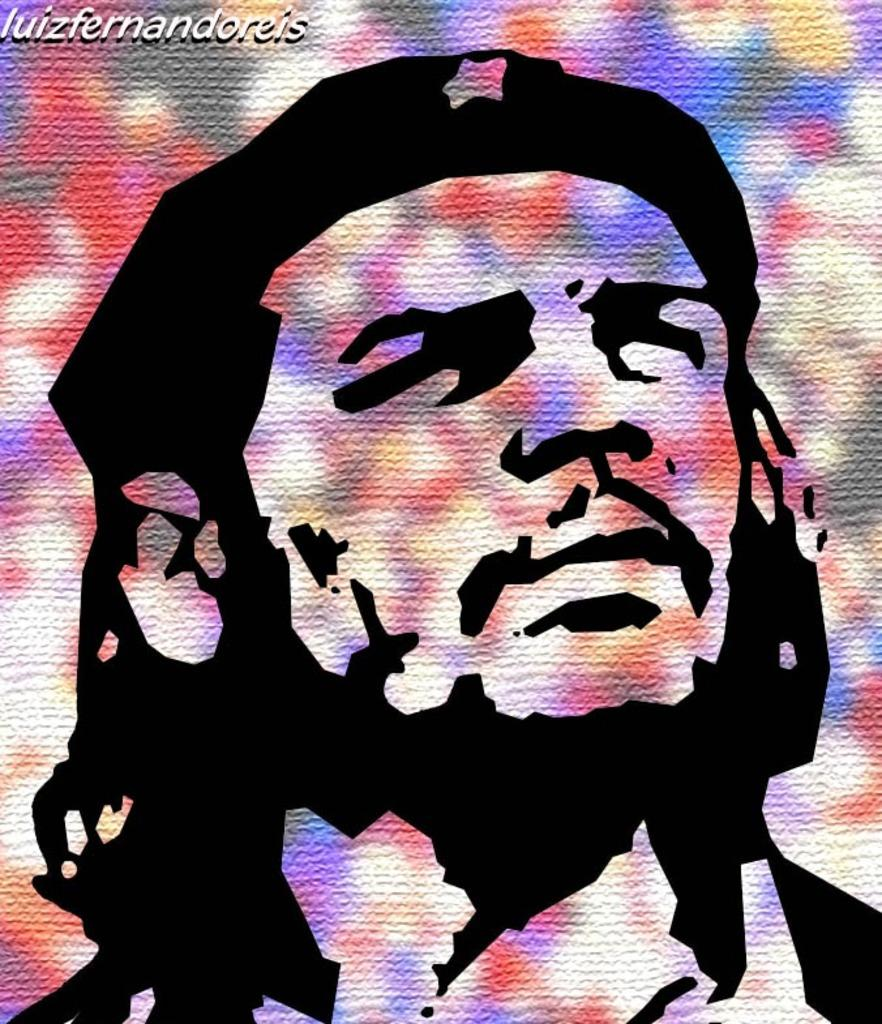What can be inferred about the image based on the given facts? The image has been edited, has a colorful background, and contains a person's face. Additionally, there is a watermark in the top left corner of the image. Can you describe the person's face in the image? Unfortunately, the facts provided do not give enough detail to describe the person's face. What is the purpose of the watermark in the image? The purpose of the watermark is not specified in the given facts. Is there any snow visible in the image? There is no mention of snow in the given facts, so it cannot be determined if snow is present in the image. What organization is responsible for the downtown area depicted in the image? The given facts do not mention a downtown area or any organization related to it, so this information cannot be determined from the image. 